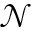<formula> <loc_0><loc_0><loc_500><loc_500>\mathcal { N }</formula> 